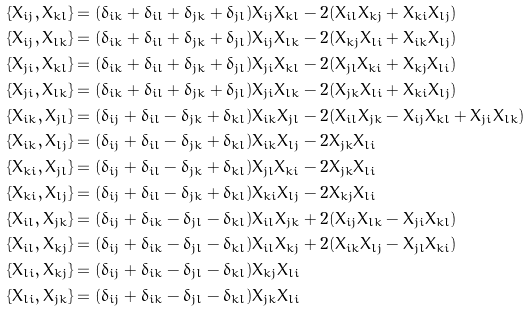Convert formula to latex. <formula><loc_0><loc_0><loc_500><loc_500>& \{ X _ { i j } , X _ { k l } \} = ( \delta _ { i k } + \delta _ { i l } + \delta _ { j k } + \delta _ { j l } ) X _ { i j } X _ { k l } - 2 ( X _ { i l } X _ { k j } + X _ { k i } X _ { l j } ) \\ & \{ X _ { i j } , X _ { l k } \} = ( \delta _ { i k } + \delta _ { i l } + \delta _ { j k } + \delta _ { j l } ) X _ { i j } X _ { l k } - 2 ( X _ { k j } X _ { l i } + X _ { i k } X _ { l j } ) \\ & \{ X _ { j i } , X _ { k l } \} = ( \delta _ { i k } + \delta _ { i l } + \delta _ { j k } + \delta _ { j l } ) X _ { j i } X _ { k l } - 2 ( X _ { j l } X _ { k i } + X _ { k j } X _ { l i } ) \\ & \{ X _ { j i } , X _ { l k } \} = ( \delta _ { i k } + \delta _ { i l } + \delta _ { j k } + \delta _ { j l } ) X _ { j i } X _ { l k } - 2 ( X _ { j k } X _ { l i } + X _ { k i } X _ { l j } ) \\ & \{ X _ { i k } , X _ { j l } \} = ( \delta _ { i j } + \delta _ { i l } - \delta _ { j k } + \delta _ { k l } ) X _ { i k } X _ { j l } - 2 ( X _ { i l } X _ { j k } - X _ { i j } X _ { k l } + X _ { j i } X _ { l k } ) \\ & \{ X _ { i k } , X _ { l j } \} = ( \delta _ { i j } + \delta _ { i l } - \delta _ { j k } + \delta _ { k l } ) X _ { i k } X _ { l j } - 2 X _ { j k } X _ { l i } \\ & \{ X _ { k i } , X _ { j l } \} = ( \delta _ { i j } + \delta _ { i l } - \delta _ { j k } + \delta _ { k l } ) X _ { j l } X _ { k i } - 2 X _ { j k } X _ { l i } \\ & \{ X _ { k i } , X _ { l j } \} = ( \delta _ { i j } + \delta _ { i l } - \delta _ { j k } + \delta _ { k l } ) X _ { k i } X _ { l j } - 2 X _ { k j } X _ { l i } \\ & \{ X _ { i l } , X _ { j k } \} = ( \delta _ { i j } + \delta _ { i k } - \delta _ { j l } - \delta _ { k l } ) X _ { i l } X _ { j k } + 2 ( X _ { i j } X _ { l k } - X _ { j i } X _ { k l } ) \\ & \{ X _ { i l } , X _ { k j } \} = ( \delta _ { i j } + \delta _ { i k } - \delta _ { j l } - \delta _ { k l } ) X _ { i l } X _ { k j } + 2 ( X _ { i k } X _ { l j } - X _ { j l } X _ { k i } ) \\ & \{ X _ { l i } , X _ { k j } \} = ( \delta _ { i j } + \delta _ { i k } - \delta _ { j l } - \delta _ { k l } ) X _ { k j } X _ { l i } \\ & \{ X _ { l i } , X _ { j k } \} = ( \delta _ { i j } + \delta _ { i k } - \delta _ { j l } - \delta _ { k l } ) X _ { j k } X _ { l i }</formula> 